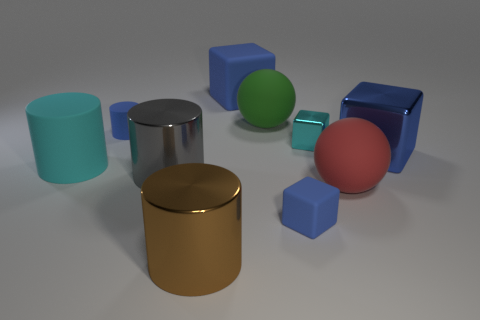How would you describe the arrangement of the objects in this image? The objects are arranged seemingly at random on a flat surface. The composition includes a variety of geometric shapes — cylinders, cubes, and spheres — in different colors which could suggest a playful or artistic setup, possibly designed to showcase contrast and diversity in shape and color.  What could be the purpose of this arrangement? This arrangement might be used for several purposes; it could be a visual rendering for a design project, a demonstration of 3D modeling, or simply an artistic display. The precise and clean rendering hints at a digital creation, most likely purposed for educational or illustrative uses, such as teaching about geometry, shading, and light in art and design. 